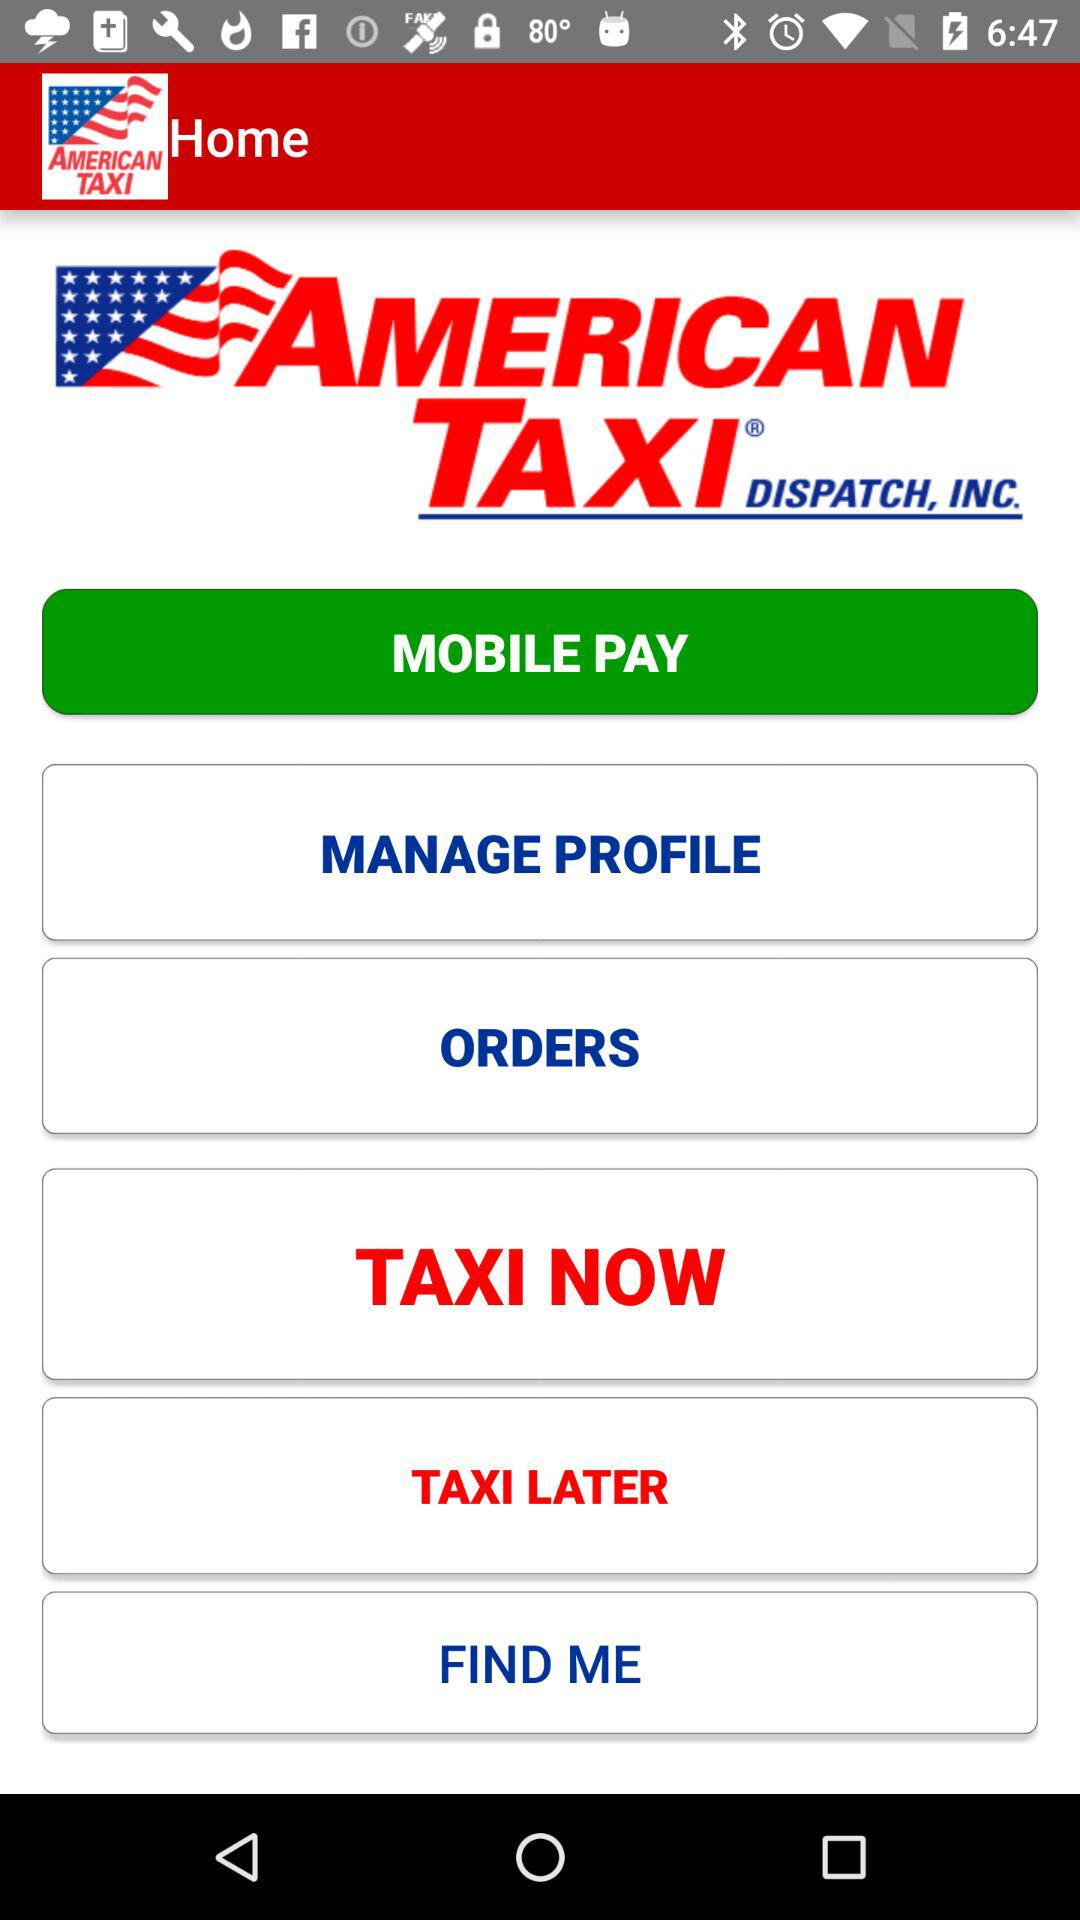What is the application name? The application name is "American Taxi Dispatch". 